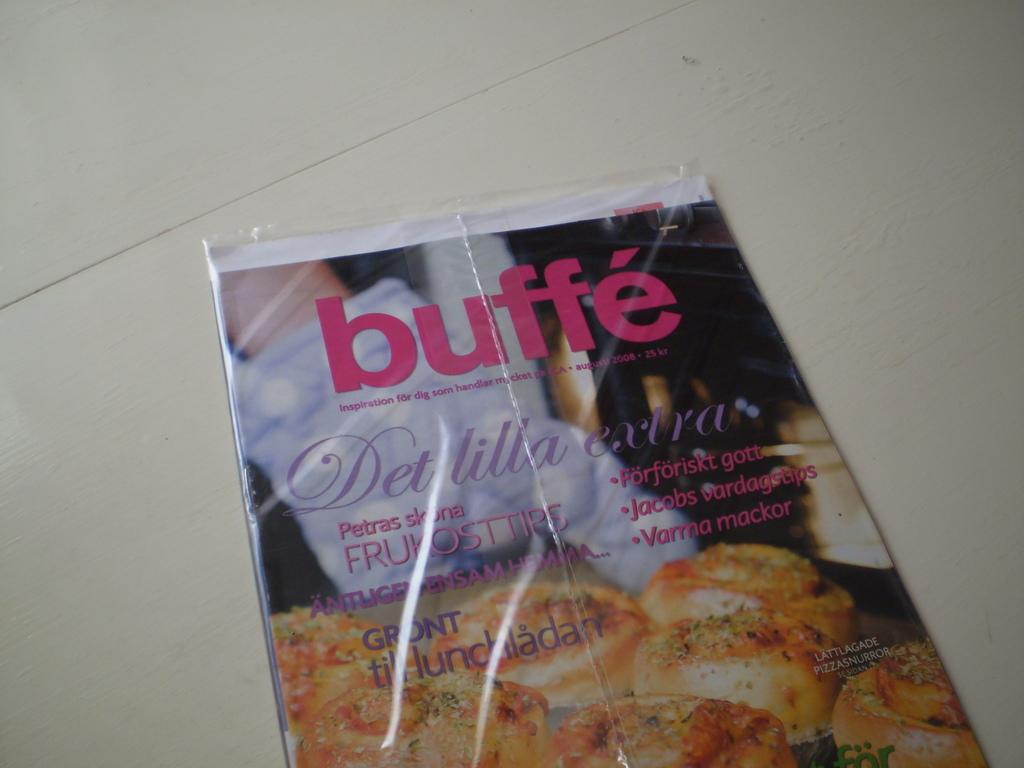What can be seen in the image? There is a magazine in the image. What is written on the magazine? The magazine has text written on it. What is the color of the background in the image? The background of the image is white in color. Is there a plant growing out of the magazine in the image? No, there is no plant growing out of the magazine in the image. 